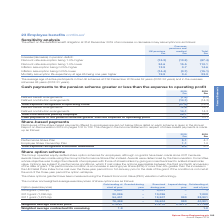According to Spirax Sarco Engineering Plc's financial document, Where can more details on each shares payment scheme be found? in the Annual Report on Remuneration 2019 on pages 102 to 132. The document states: "et out below. More detail on each scheme is given in the Annual Report on Remuneration 2019 on pages 102 to 132. The charge to the Income Statement in..." Also, What is the total expense recognised in Income Statement in 2019? According to the financial document, 6.2 (in millions). The relevant text states: "1.0 Total expense recognised in Income Statement 6.2 5.7..." Also, What are the types of plans for the share-based payments offered to employees in the table? The document shows two values: Performance Share Plan and Employee Share Ownership Plan. From the document: "2018 £m Performance Share Plan 5.1 4.7 Employee Share Ownership Plan 1.1 1.0 Total expense recognised in Income Statement 6.2 5.7 2018 £m Performance ..." Additionally, In which year was the amount for Employee Share Ownership Plan value larger? According to the financial document, 2019. The relevant text states: "Annual Report 2019..." Also, can you calculate: What was the change in the amount for Performance Share Plan from 2018 to 2019? Based on the calculation: 5.1-4.7, the result is 0.4 (in millions). This is based on the information: "2018 £m Performance Share Plan 5.1 4.7 Employee Share Ownership Plan 1.1 1.0 Total expense recognised in Income Statement 6.2 5.7 2018 £m Performance Share Plan 5.1 4.7 Employee Share Ownership Plan 1..." The key data points involved are: 4.7, 5.1. Also, can you calculate: What was the percentage change in the amount for Performance Share Plan from 2018 to 2019? To answer this question, I need to perform calculations using the financial data. The calculation is: (5.1-4.7)/4.7, which equals 8.51 (percentage). This is based on the information: "2018 £m Performance Share Plan 5.1 4.7 Employee Share Ownership Plan 1.1 1.0 Total expense recognised in Income Statement 6.2 5.7 2018 £m Performance Share Plan 5.1 4.7 Employee Share Ownership Plan 1..." The key data points involved are: 4.7, 5.1. 